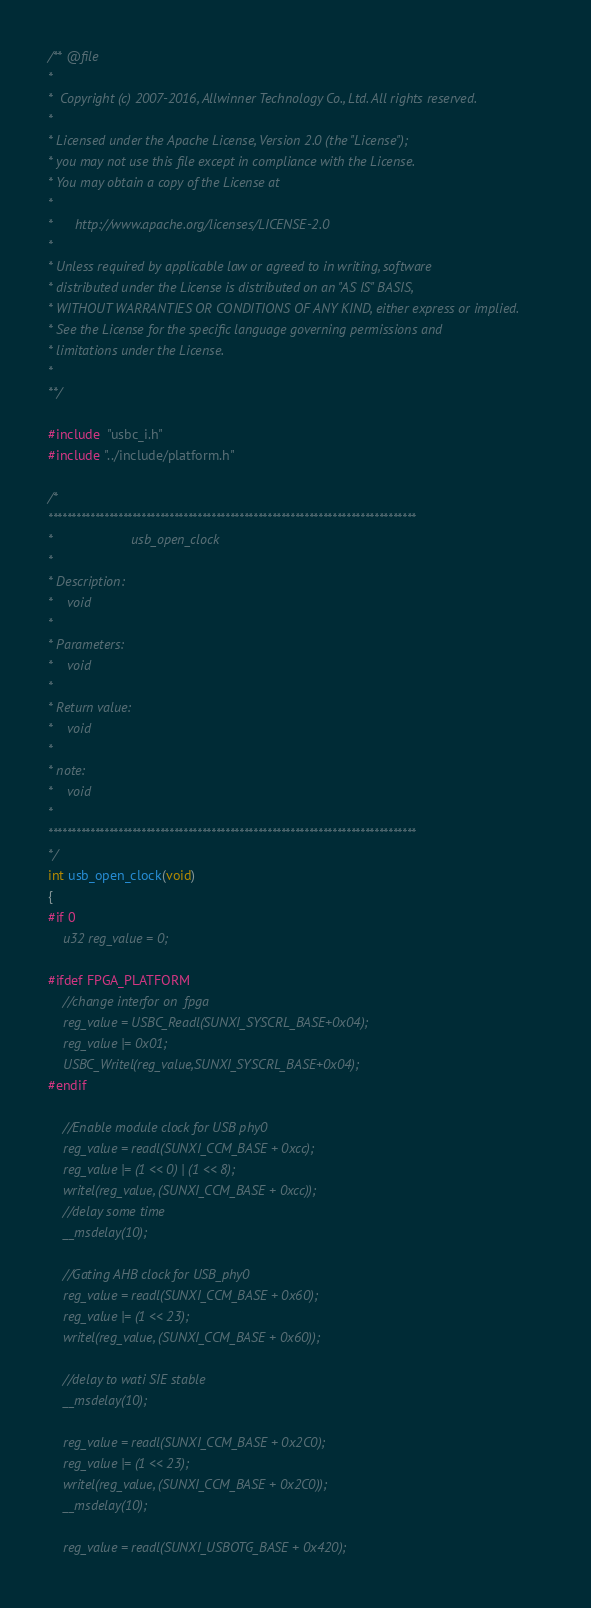Convert code to text. <code><loc_0><loc_0><loc_500><loc_500><_C_>/** @file
*
*  Copyright (c) 2007-2016, Allwinner Technology Co., Ltd. All rights reserved.
*
* Licensed under the Apache License, Version 2.0 (the "License");
* you may not use this file except in compliance with the License.
* You may obtain a copy of the License at
*
*      http://www.apache.org/licenses/LICENSE-2.0
*
* Unless required by applicable law or agreed to in writing, software
* distributed under the License is distributed on an "AS IS" BASIS,
* WITHOUT WARRANTIES OR CONDITIONS OF ANY KIND, either express or implied.
* See the License for the specific language governing permissions and
* limitations under the License.
*
**/

#include  "usbc_i.h"
#include "../include/platform.h"

/*
*******************************************************************************
*                     usb_open_clock
*
* Description:
*    void
*
* Parameters:
*    void
*
* Return value:
*    void
*
* note:
*    void
*
*******************************************************************************
*/
int usb_open_clock(void)
{
#if 0
	u32 reg_value = 0;

#ifdef FPGA_PLATFORM
	//change interfor on  fpga 
	reg_value = USBC_Readl(SUNXI_SYSCRL_BASE+0x04);
	reg_value |= 0x01;
	USBC_Writel(reg_value,SUNXI_SYSCRL_BASE+0x04);
#endif

	//Enable module clock for USB phy0
	reg_value = readl(SUNXI_CCM_BASE + 0xcc);
	reg_value |= (1 << 0) | (1 << 8);
	writel(reg_value, (SUNXI_CCM_BASE + 0xcc));
	//delay some time
	__msdelay(10);

	//Gating AHB clock for USB_phy0
	reg_value = readl(SUNXI_CCM_BASE + 0x60);
	reg_value |= (1 << 23);
	writel(reg_value, (SUNXI_CCM_BASE + 0x60));

	//delay to wati SIE stable
	__msdelay(10);

	reg_value = readl(SUNXI_CCM_BASE + 0x2C0);
	reg_value |= (1 << 23);
	writel(reg_value, (SUNXI_CCM_BASE + 0x2C0));
	__msdelay(10);

	reg_value = readl(SUNXI_USBOTG_BASE + 0x420);</code> 